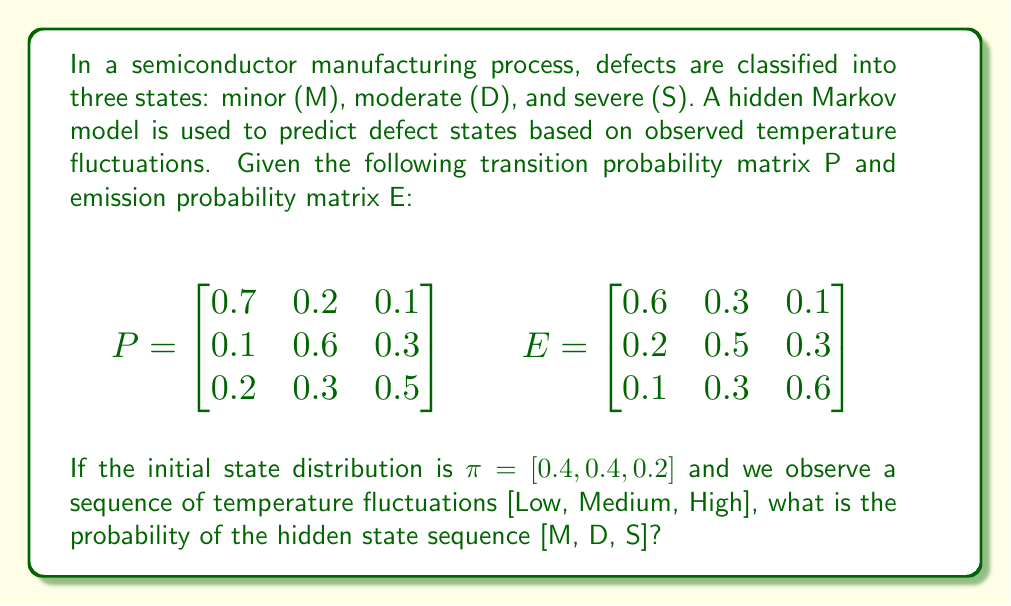Could you help me with this problem? To solve this problem, we'll use the Forward algorithm for Hidden Markov Models:

1. Define variables:
   - $\pi$ : Initial state distribution
   - P : Transition probability matrix
   - E : Emission probability matrix
   - O : Observation sequence [Low, Medium, High]
   - S : Hidden state sequence [M, D, S]

2. Calculate the probability:
   $P(O, S) = \pi_{s_1} \cdot e_{s_1}(o_1) \cdot p_{s_1s_2} \cdot e_{s_2}(o_2) \cdot p_{s_2s_3} \cdot e_{s_3}(o_3)$

   Where:
   - $\pi_{s_1}$ : Initial probability of state M
   - $e_{s_1}(o_1)$ : Emission probability of Low in state M
   - $p_{s_1s_2}$ : Transition probability from M to D
   - $e_{s_2}(o_2)$ : Emission probability of Medium in state D
   - $p_{s_2s_3}$ : Transition probability from D to S
   - $e_{s_3}(o_3)$ : Emission probability of High in state S

3. Substitute values:
   $P(O, S) = 0.4 \cdot 0.6 \cdot 0.2 \cdot 0.5 \cdot 0.3 \cdot 0.6$

4. Calculate the final probability:
   $P(O, S) = 0.4 \cdot 0.6 \cdot 0.2 \cdot 0.5 \cdot 0.3 \cdot 0.6 = 0.00144$
Answer: 0.00144 